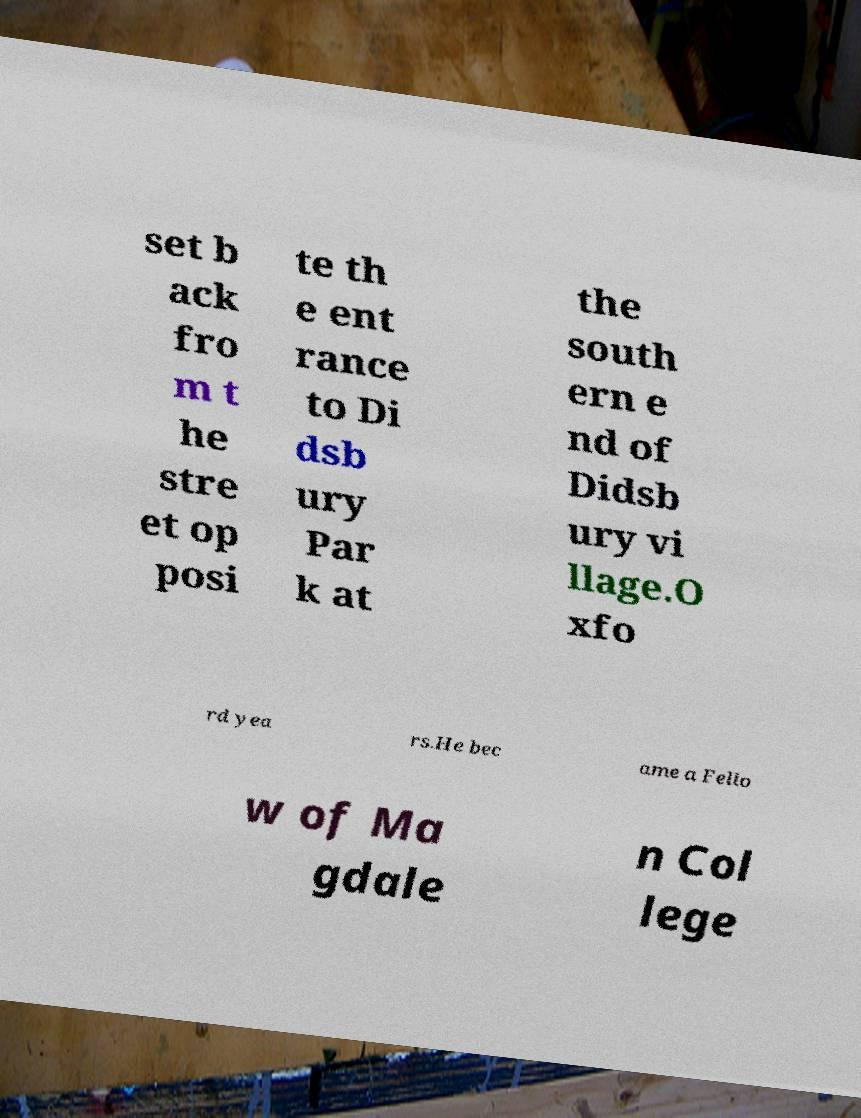Could you assist in decoding the text presented in this image and type it out clearly? set b ack fro m t he stre et op posi te th e ent rance to Di dsb ury Par k at the south ern e nd of Didsb ury vi llage.O xfo rd yea rs.He bec ame a Fello w of Ma gdale n Col lege 